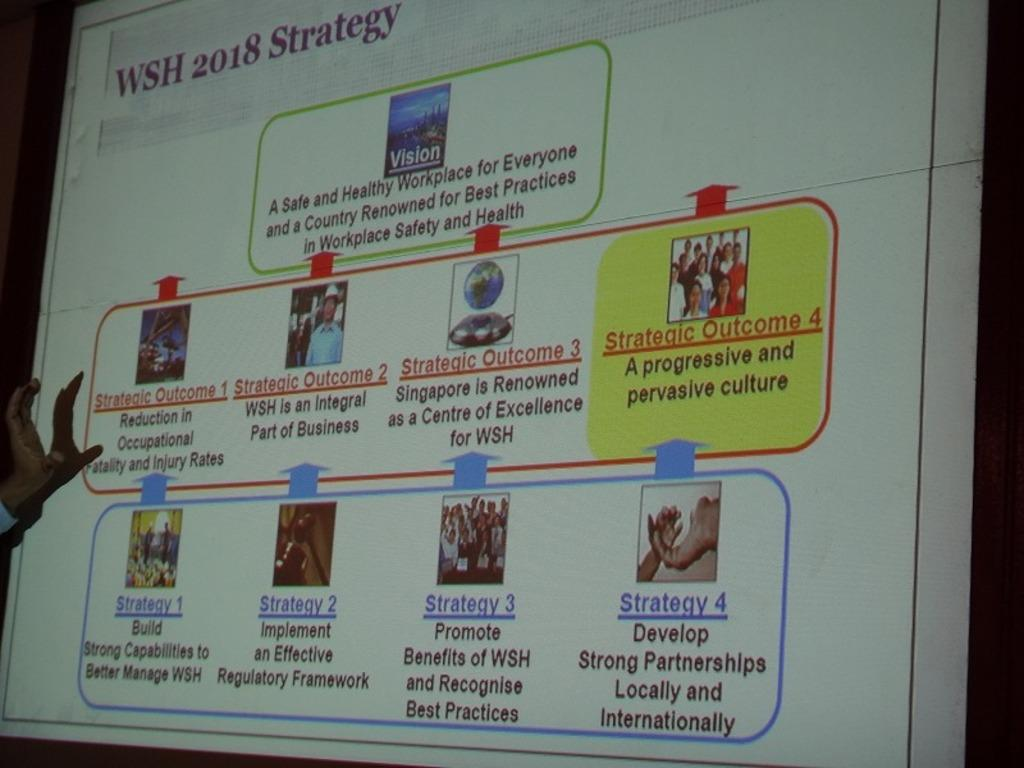<image>
Share a concise interpretation of the image provided. A screen showing many strategies named "WSH 2018 Strategy". 